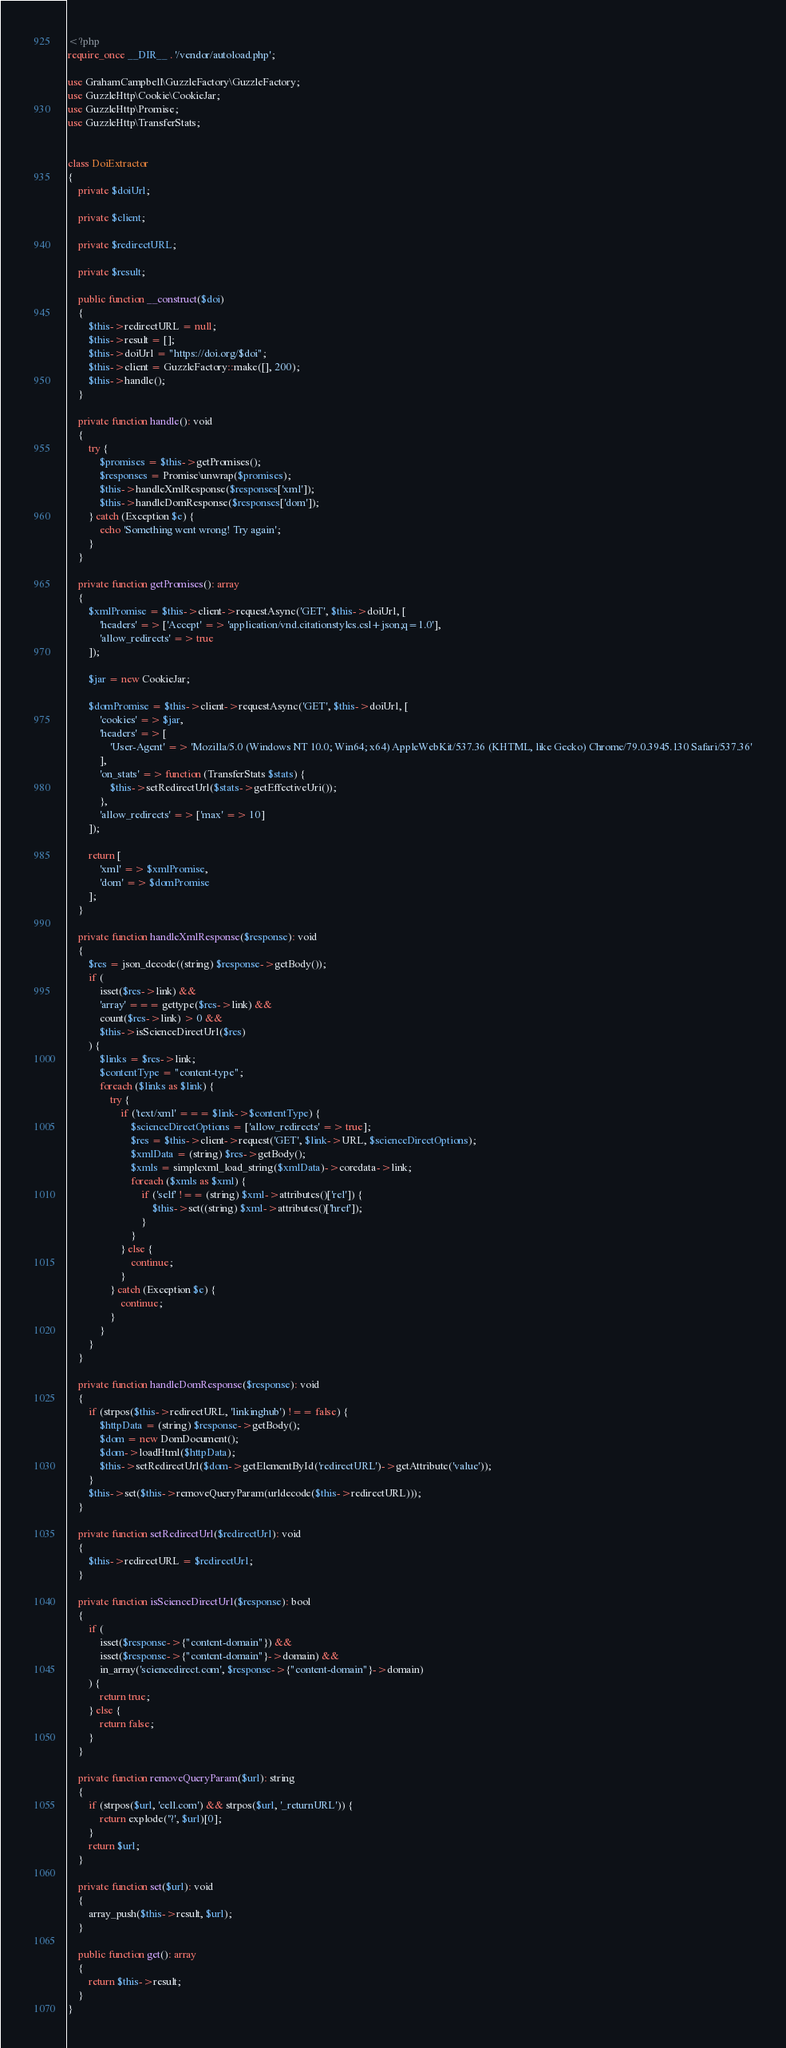Convert code to text. <code><loc_0><loc_0><loc_500><loc_500><_PHP_><?php
require_once __DIR__ . '/vendor/autoload.php';

use GrahamCampbell\GuzzleFactory\GuzzleFactory;
use GuzzleHttp\Cookie\CookieJar;
use GuzzleHttp\Promise;
use GuzzleHttp\TransferStats;


class DoiExtractor
{
	private $doiUrl;

	private $client;

	private $redirectURL;

	private $result;

	public function __construct($doi)
	{
		$this->redirectURL = null;
		$this->result = [];
		$this->doiUrl = "https://doi.org/$doi";
		$this->client = GuzzleFactory::make([], 200);
		$this->handle();
	}

	private function handle(): void
	{
		try {
			$promises = $this->getPromises();
			$responses = Promise\unwrap($promises);
			$this->handleXmlResponse($responses['xml']);
			$this->handleDomResponse($responses['dom']);
		} catch (Exception $e) {
			echo 'Something went wrong! Try again';
		}
	}

	private function getPromises(): array
	{
		$xmlPromise = $this->client->requestAsync('GET', $this->doiUrl, [
			'headers' => ['Accept' => 'application/vnd.citationstyles.csl+json;q=1.0'],
			'allow_redirects' => true
		]);

		$jar = new CookieJar;

		$domPromise = $this->client->requestAsync('GET', $this->doiUrl, [
			'cookies' => $jar,
			'headers' => [
				'User-Agent' => 'Mozilla/5.0 (Windows NT 10.0; Win64; x64) AppleWebKit/537.36 (KHTML, like Gecko) Chrome/79.0.3945.130 Safari/537.36'
			],
			'on_stats' => function (TransferStats $stats) {
				$this->setRedirectUrl($stats->getEffectiveUri());
			},
			'allow_redirects' => ['max' => 10]
		]);

		return [
			'xml' => $xmlPromise,
			'dom' => $domPromise
		];
	}

	private function handleXmlResponse($response): void
	{
		$res = json_decode((string) $response->getBody());
		if (
			isset($res->link) &&
			'array' === gettype($res->link) &&
			count($res->link) > 0 &&
			$this->isScienceDirectUrl($res)
		) {
			$links = $res->link;
			$contentType = "content-type";
			foreach ($links as $link) {
				try {
					if ('text/xml' === $link->$contentType) {
						$scienceDirectOptions = ['allow_redirects' => true];
						$res = $this->client->request('GET', $link->URL, $scienceDirectOptions);
						$xmlData = (string) $res->getBody();
						$xmls = simplexml_load_string($xmlData)->coredata->link;
						foreach ($xmls as $xml) {
							if ('self' !== (string) $xml->attributes()['rel']) {
								$this->set((string) $xml->attributes()['href']);
							}
						}
					} else {
						continue;
					}
				} catch (Exception $e) {
					continue;
				}
			}
		}
	}

	private function handleDomResponse($response): void
	{
		if (strpos($this->redirectURL, 'linkinghub') !== false) {
			$httpData = (string) $response->getBody();
			$dom = new DomDocument();
			$dom->loadHtml($httpData);
			$this->setRedirectUrl($dom->getElementById('redirectURL')->getAttribute('value'));
		}
		$this->set($this->removeQueryParam(urldecode($this->redirectURL)));
	}

	private function setRedirectUrl($redirectUrl): void
	{
		$this->redirectURL = $redirectUrl;
	}

	private function isScienceDirectUrl($response): bool
	{
		if (
			isset($response->{"content-domain"}) &&
			isset($response->{"content-domain"}->domain) &&
			in_array('sciencedirect.com', $response->{"content-domain"}->domain)
		) {
			return true;
		} else {
			return false;
		}
	}

	private function removeQueryParam($url): string
	{
		if (strpos($url, 'cell.com') && strpos($url, '_returnURL')) {
			return explode('?', $url)[0];
		}
		return $url;
	}

	private function set($url): void
	{
		array_push($this->result, $url);
	}

	public function get(): array
	{
		return $this->result;
	}
}
</code> 